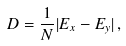Convert formula to latex. <formula><loc_0><loc_0><loc_500><loc_500>D = \frac { 1 } { N } | E _ { x } - E _ { y } | \, ,</formula> 